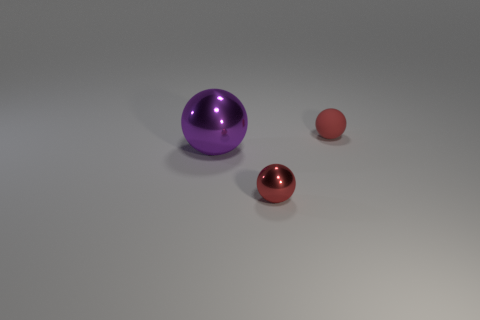What is the material of the small thing that is the same color as the tiny metallic ball?
Provide a short and direct response. Rubber. How many other large metallic things are the same color as the large thing?
Provide a short and direct response. 0. There is a purple ball; is its size the same as the red sphere that is left of the small rubber object?
Give a very brief answer. No. There is a red object that is to the left of the small red object right of the thing that is in front of the big shiny ball; what size is it?
Ensure brevity in your answer.  Small. How many small objects are behind the large shiny sphere?
Give a very brief answer. 1. What material is the small ball that is to the right of the metal object to the right of the purple thing made of?
Keep it short and to the point. Rubber. Is there anything else that is the same size as the purple sphere?
Keep it short and to the point. No. Is the purple metal sphere the same size as the red rubber object?
Your answer should be very brief. No. What number of things are small red metallic balls on the left side of the matte sphere or small things in front of the big purple sphere?
Provide a short and direct response. 1. Are there more tiny matte spheres that are to the right of the small red matte sphere than yellow metallic things?
Make the answer very short. No. 